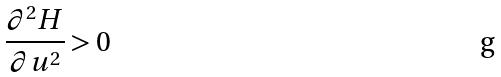<formula> <loc_0><loc_0><loc_500><loc_500>\frac { \partial ^ { 2 } H } { \partial u ^ { 2 } } > 0</formula> 